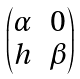Convert formula to latex. <formula><loc_0><loc_0><loc_500><loc_500>\begin{pmatrix} \alpha & 0 \\ h & \beta \end{pmatrix}</formula> 